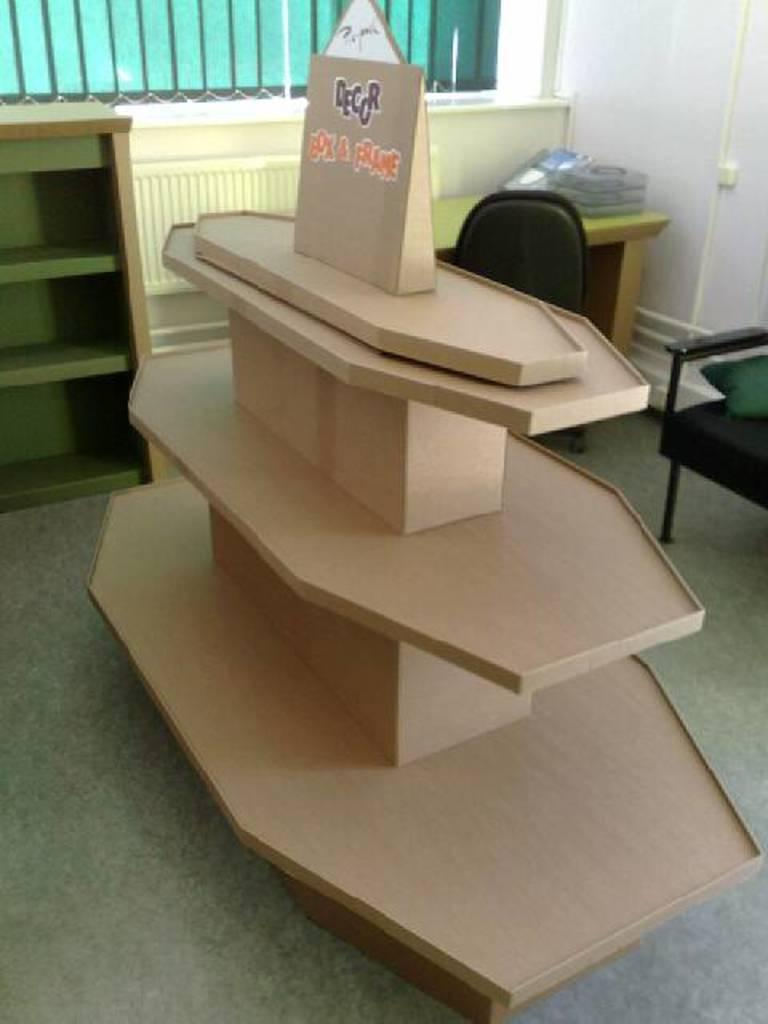What type of furniture is present in the image? There is a rack and a chair in the image. What color is the object mentioned in the image? There is a brown color object in the image. Where are the objects placed in the image? There are objects on a table in the image. What architectural features can be seen in the image? There is a wall and a window in the image. How many tomatoes are on the rack in the image? There are no tomatoes present in the image; the facts provided do not mention any tomatoes. What type of cap is the person wearing in the image? There is no person or cap visible in the image. 